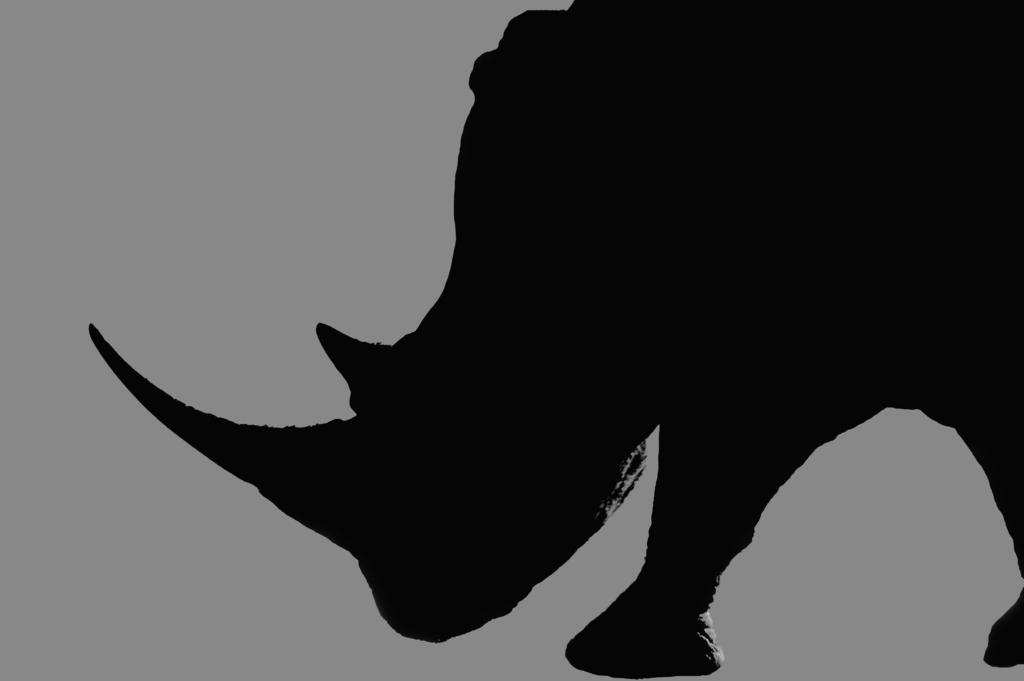What is the main subject of the image? The main subject of the image is a shadow of a rhinoceros. What color is the background of the image? The background of the image is grey in color. How many roses are present on the table in the image? There are no roses or tables present in the image; it features a shadow of a rhinoceros and a grey background. What type of party is being depicted in the image? There is no party depicted in the image; it features a shadow of a rhinoceros and a grey background. 